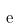<formula> <loc_0><loc_0><loc_500><loc_500>\tilde { e }</formula> 